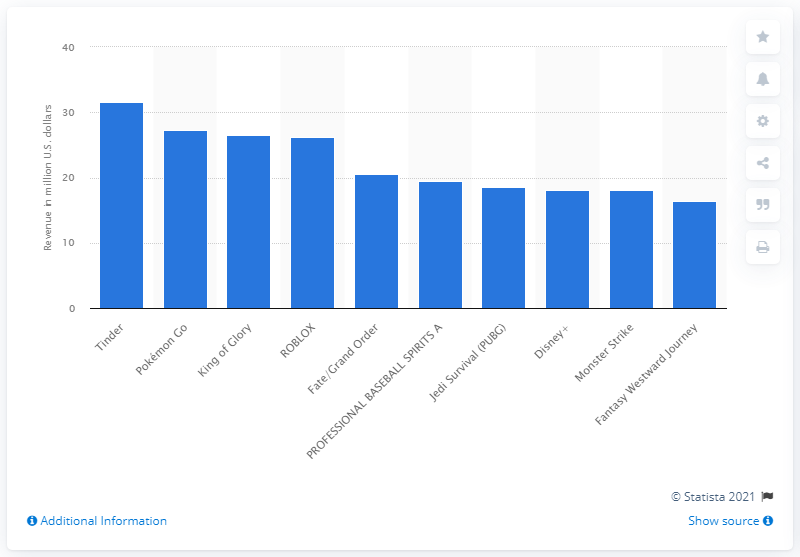Mention a couple of crucial points in this snapshot. Tinder generated approximately 31.64 million dollars in revenue from iOS users in the last fiscal year. In February 2021, Tinder was the top-grossing iPhone app in the Apple App Store. 